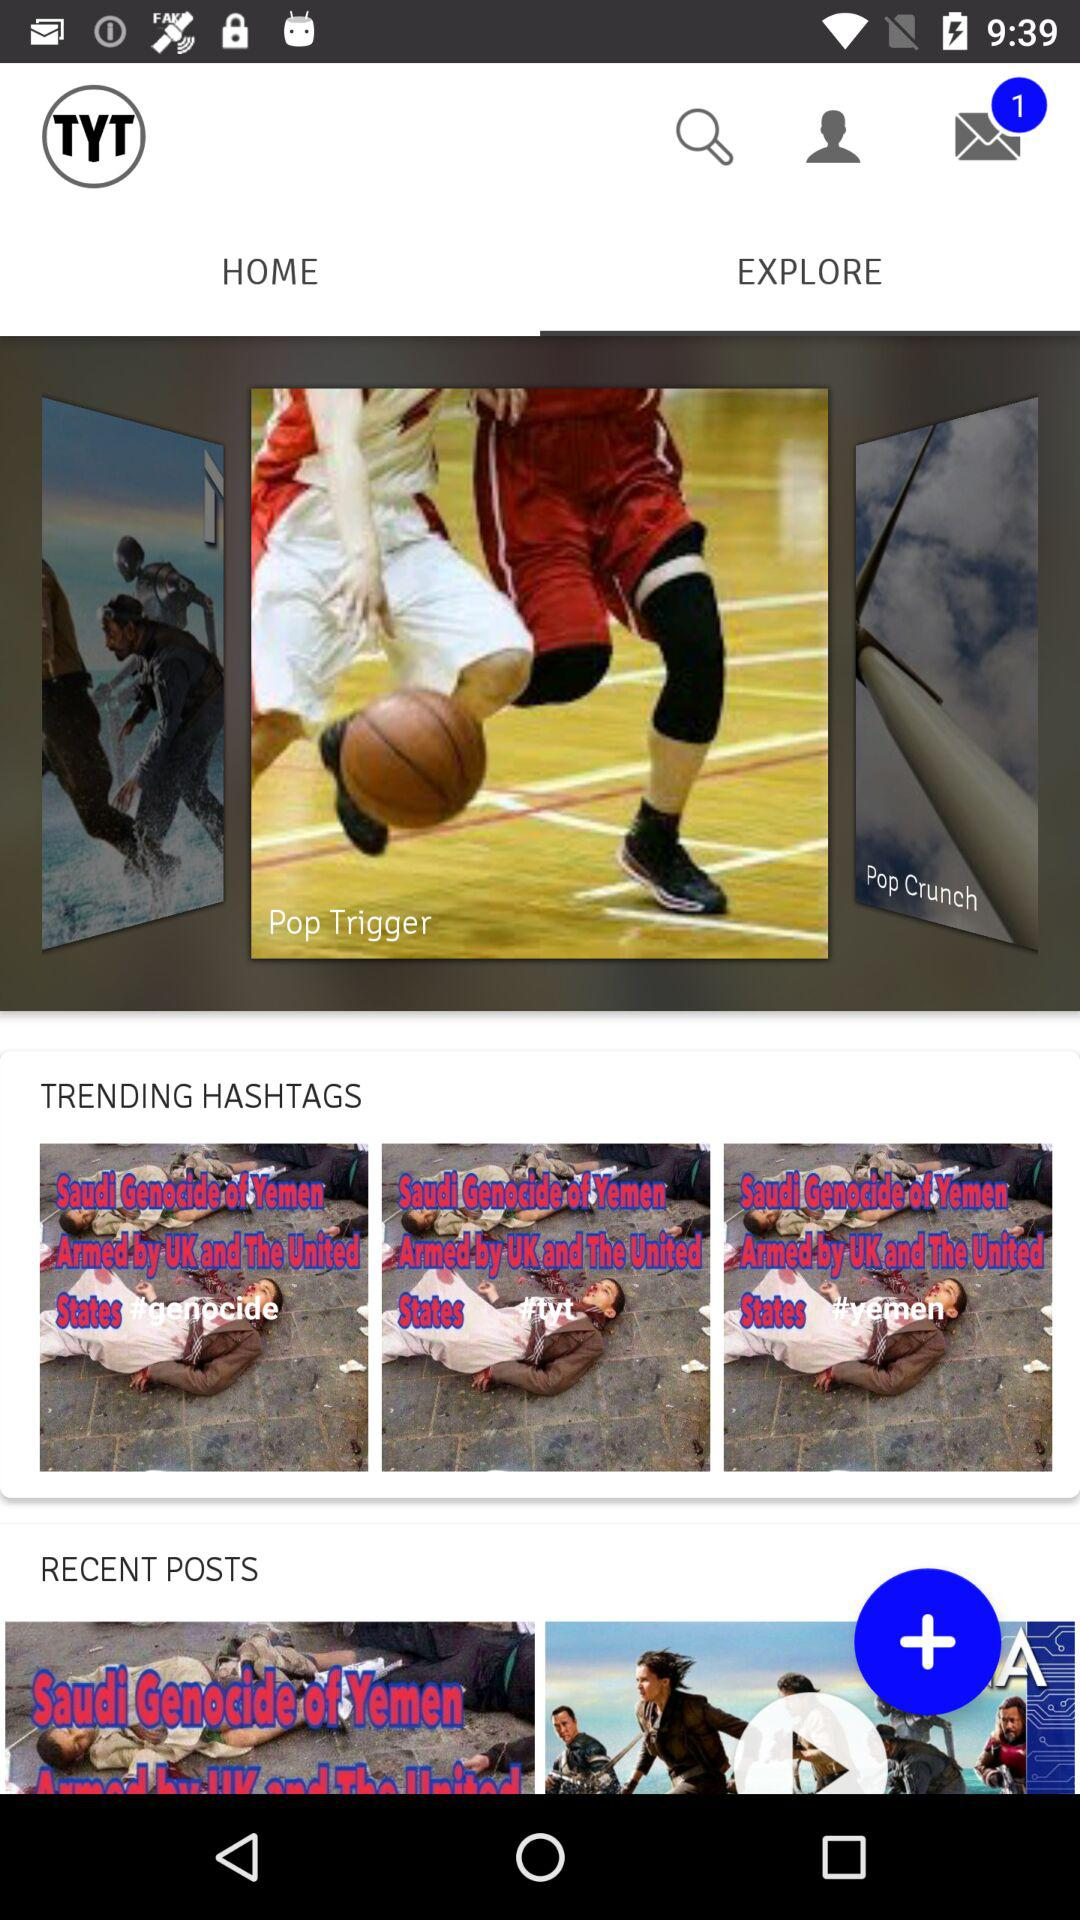Which tab is selected? The selected tab is "EXPLORE". 